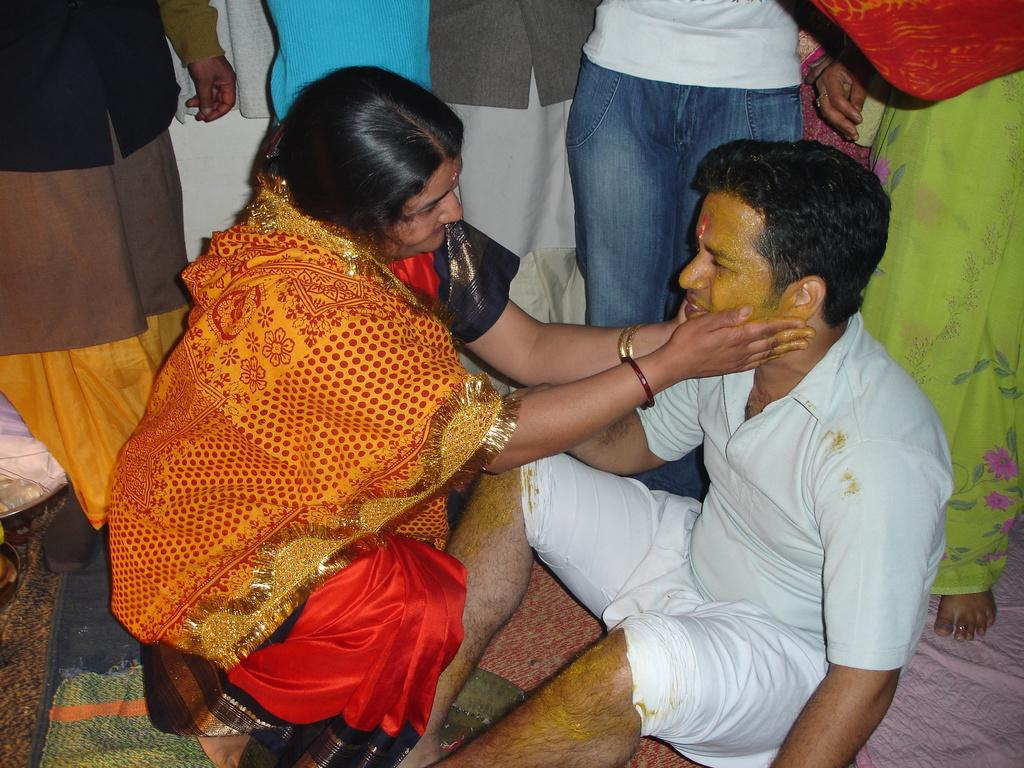How many people are in the image? There are two persons in the image. What is one person doing to the other person's face? One person is applying turmeric to the other person's face. Can you describe any other visible body parts in the image? There are legs visible in the image, likely belonging to other persons. How many tickets are visible in the image? There are no tickets present in the image. What type of sack can be seen in the image? There is no sack present in the image. 